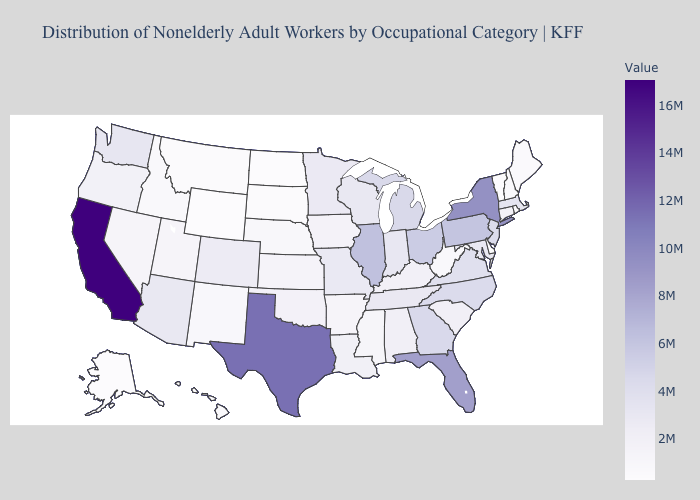Does Florida have the highest value in the USA?
Quick response, please. No. Does Alabama have the lowest value in the South?
Answer briefly. No. Which states hav the highest value in the Northeast?
Concise answer only. New York. 